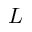Convert formula to latex. <formula><loc_0><loc_0><loc_500><loc_500>L</formula> 